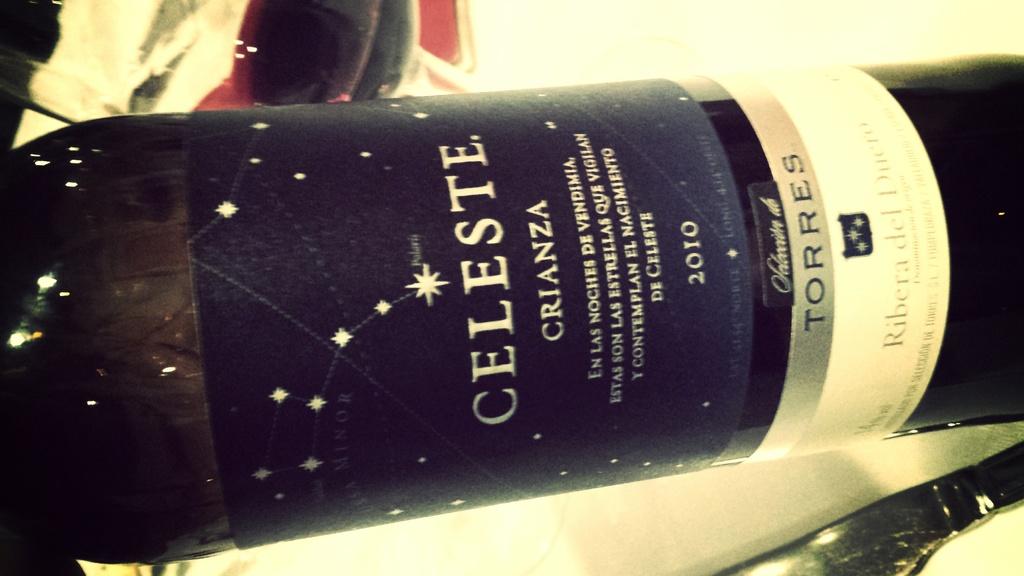What year is listed?
Your answer should be very brief. 2010. 